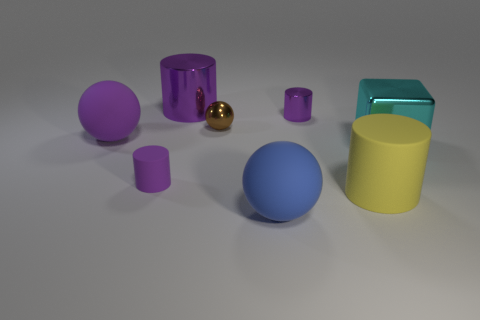Subtract all purple cylinders. How many were subtracted if there are1purple cylinders left? 2 Subtract all tiny rubber cylinders. How many cylinders are left? 3 Subtract all yellow cylinders. How many cylinders are left? 3 Subtract all brown balls. How many purple cylinders are left? 3 Add 1 tiny shiny things. How many objects exist? 9 Subtract all balls. How many objects are left? 5 Subtract all yellow balls. Subtract all red cylinders. How many balls are left? 3 Subtract all big shiny cylinders. Subtract all rubber cylinders. How many objects are left? 5 Add 8 small matte cylinders. How many small matte cylinders are left? 9 Add 4 tiny green things. How many tiny green things exist? 4 